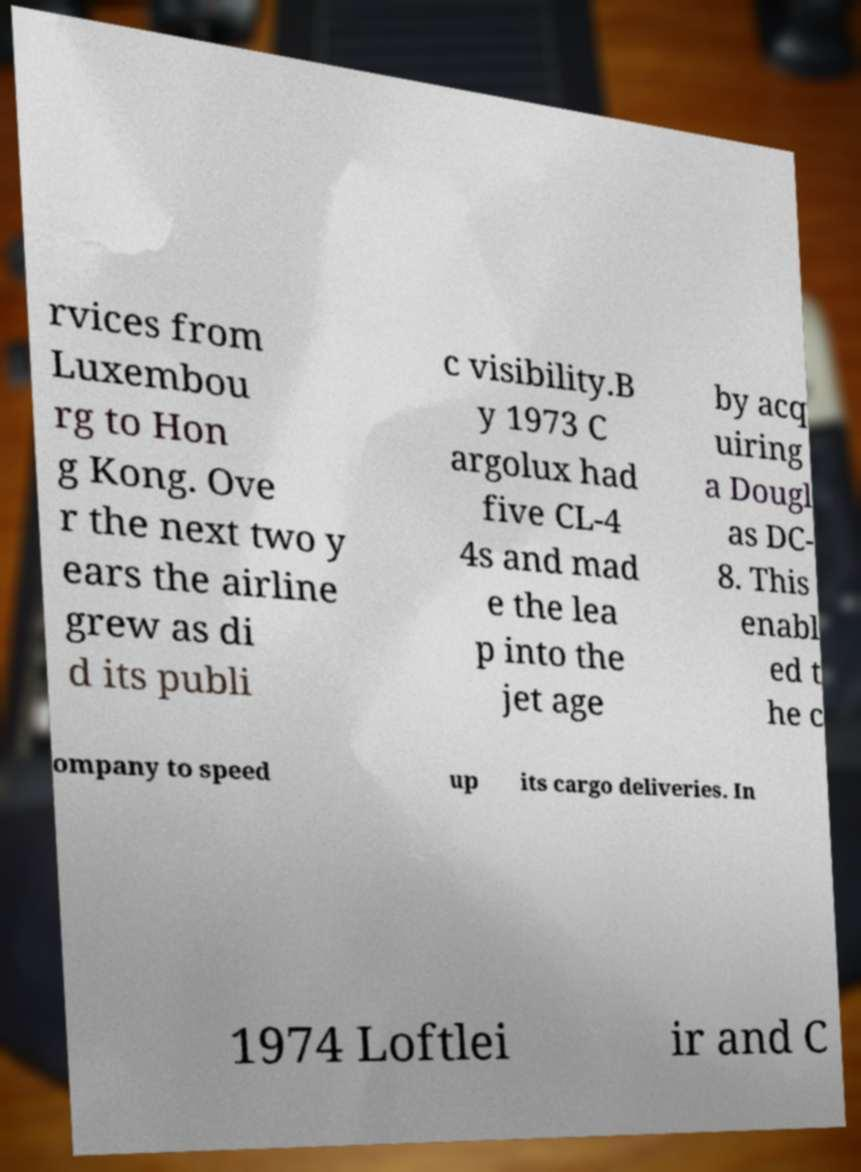For documentation purposes, I need the text within this image transcribed. Could you provide that? rvices from Luxembou rg to Hon g Kong. Ove r the next two y ears the airline grew as di d its publi c visibility.B y 1973 C argolux had five CL-4 4s and mad e the lea p into the jet age by acq uiring a Dougl as DC- 8. This enabl ed t he c ompany to speed up its cargo deliveries. In 1974 Loftlei ir and C 